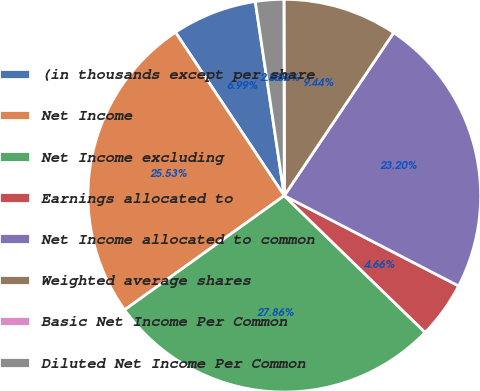Convert chart to OTSL. <chart><loc_0><loc_0><loc_500><loc_500><pie_chart><fcel>(in thousands except per share<fcel>Net Income<fcel>Net Income excluding<fcel>Earnings allocated to<fcel>Net Income allocated to common<fcel>Weighted average shares<fcel>Basic Net Income Per Common<fcel>Diluted Net Income Per Common<nl><fcel>6.99%<fcel>25.53%<fcel>27.86%<fcel>4.66%<fcel>23.2%<fcel>9.44%<fcel>0.0%<fcel>2.33%<nl></chart> 